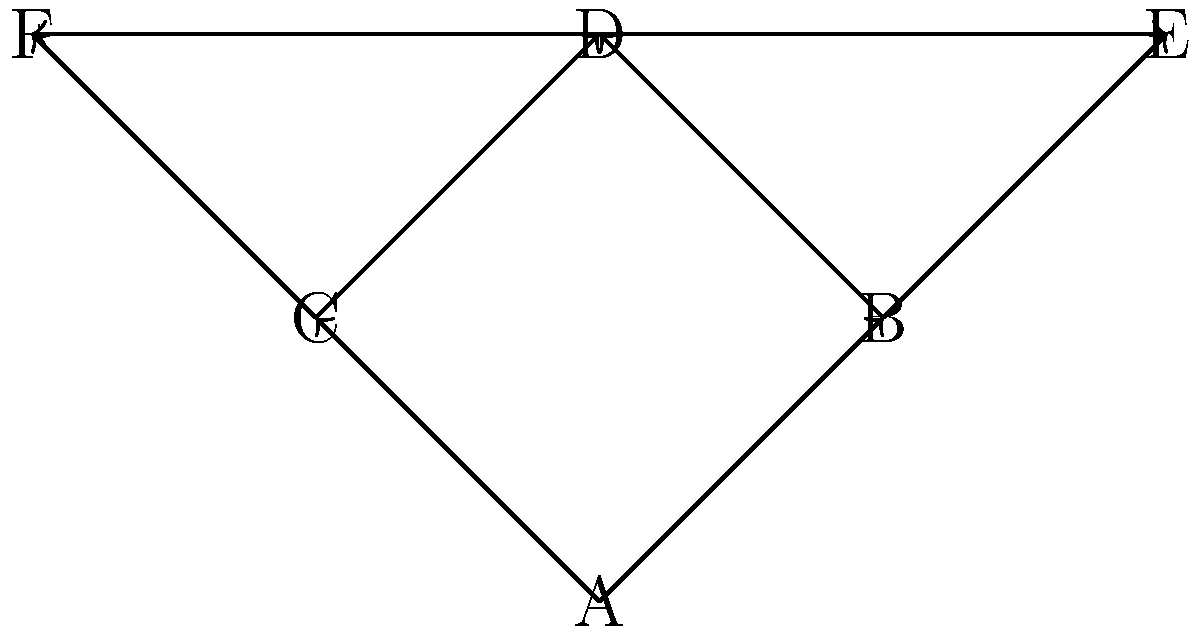In the access control graph shown, where nodes represent system components and edges represent access paths, which node(s) should be prioritized for enhanced security measures to minimize the risk of unauthorized data breaches? Explain your reasoning based on the graph structure. To identify the critical nodes in this access control graph, we need to analyze the structure and connectivity of the graph. Here's a step-by-step explanation:

1. Observe the overall structure:
   The graph has 6 nodes (A, B, C, D, E, F) connected by directed edges.

2. Identify the root node:
   Node A is the only node with no incoming edges, making it the root or entry point of the system.

3. Analyze node connectivity:
   - Node A connects to B and C
   - Nodes B and C both connect to D
   - Node B connects to E
   - Node C connects to F
   - Node D connects to both E and F

4. Identify critical nodes:
   a) Node A is critical as it's the entry point for all paths.
   b) Node D is critical because:
      - It's a central node in the graph
      - It connects to both E and F
      - All paths from A to E or F must pass through either B or C, and then D

5. Assess impact:
   - Compromising node A would give access to the entire system
   - Compromising node D would allow access to both E and F, regardless of whether B or C was used to reach D

6. Consider security implications:
   - Strengthening security at node A is crucial to protect the entire system
   - Enhancing security at node D is important to prevent unauthorized access to E and F

Therefore, nodes A and D should be prioritized for enhanced security measures. Node A is the most critical as it's the entry point, while node D is the second most critical due to its central position and connectivity to other important nodes.
Answer: Nodes A and D 